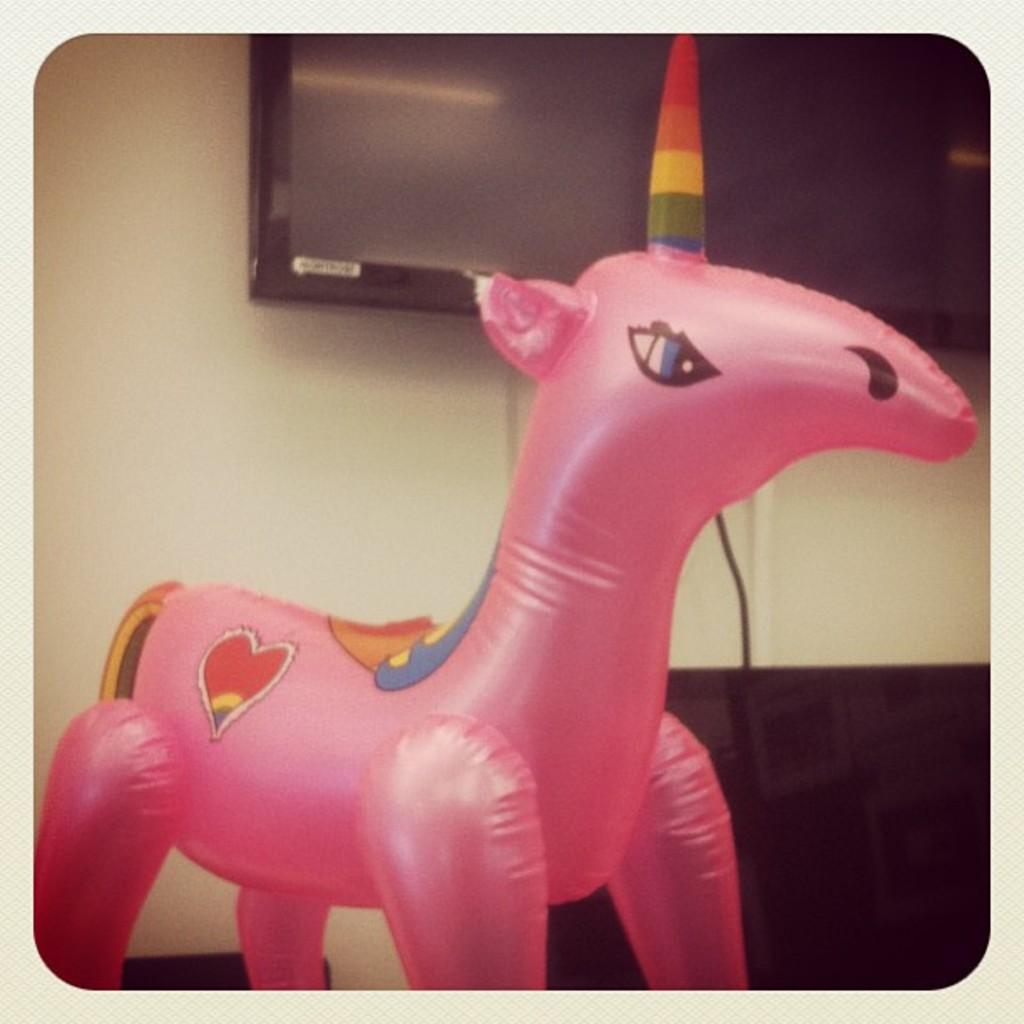What is the nature of the image? The image appears to be edited. What type of object can be seen floating in the image? There is an inflatable unicorn in the image. What is visible in the background of the image? There is a wall in the background of the image. What is mounted on the wall? A television is present on the wall. What is connected to the television? A cable is visible near the television. How many cows are present in the image? There are no cows present in the image. What type of cracker is being used to join the inflatable unicorn to the wall? There is no cracker or any object being used to join the inflatable unicorn to the wall in the image. 